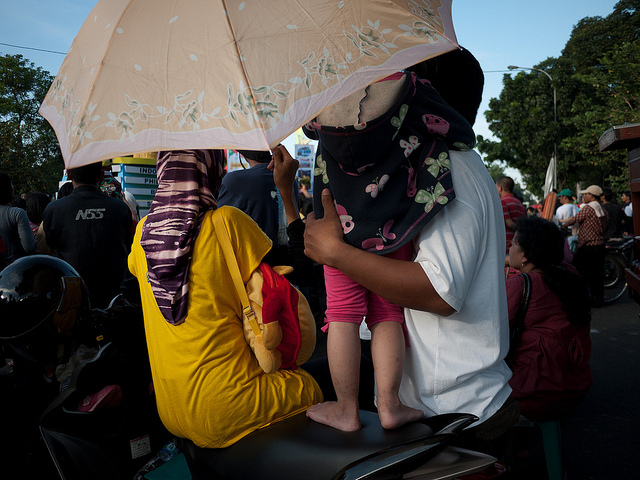<image>What kind of animal can be seen in the picture? I don't know. The animal can be a dog, butterfly, bear, bird, or human. What logo is in the umbrella? I am not sure what logo is in the umbrella. It could have none, flowers, lazyboy or flower. What kind of animal can be seen in the picture? There are multiple possibilities of the kind of animal that can be seen in the picture. It can be either a dog, butterfly, human, bird, or bear. What logo is in the umbrella? I am not sure what logo is on the umbrella. It is possible that there is no logo or it can be flowers. 